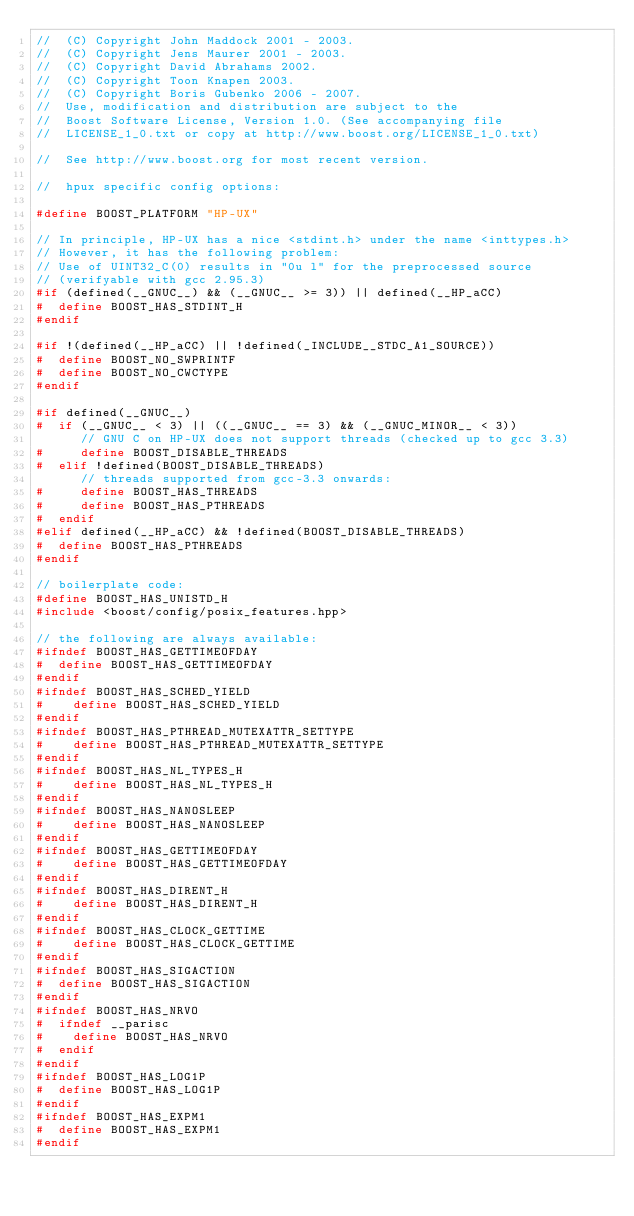Convert code to text. <code><loc_0><loc_0><loc_500><loc_500><_C++_>//  (C) Copyright John Maddock 2001 - 2003. 
//  (C) Copyright Jens Maurer 2001 - 2003. 
//  (C) Copyright David Abrahams 2002. 
//  (C) Copyright Toon Knapen 2003. 
//  (C) Copyright Boris Gubenko 2006 - 2007.
//  Use, modification and distribution are subject to the 
//  Boost Software License, Version 1.0. (See accompanying file 
//  LICENSE_1_0.txt or copy at http://www.boost.org/LICENSE_1_0.txt)

//  See http://www.boost.org for most recent version.

//  hpux specific config options:

#define BOOST_PLATFORM "HP-UX"

// In principle, HP-UX has a nice <stdint.h> under the name <inttypes.h>
// However, it has the following problem:
// Use of UINT32_C(0) results in "0u l" for the preprocessed source
// (verifyable with gcc 2.95.3)
#if (defined(__GNUC__) && (__GNUC__ >= 3)) || defined(__HP_aCC)
#  define BOOST_HAS_STDINT_H
#endif

#if !(defined(__HP_aCC) || !defined(_INCLUDE__STDC_A1_SOURCE))
#  define BOOST_NO_SWPRINTF
#  define BOOST_NO_CWCTYPE
#endif

#if defined(__GNUC__)
#  if (__GNUC__ < 3) || ((__GNUC__ == 3) && (__GNUC_MINOR__ < 3))
      // GNU C on HP-UX does not support threads (checked up to gcc 3.3)
#     define BOOST_DISABLE_THREADS
#  elif !defined(BOOST_DISABLE_THREADS)
      // threads supported from gcc-3.3 onwards:
#     define BOOST_HAS_THREADS
#     define BOOST_HAS_PTHREADS
#  endif
#elif defined(__HP_aCC) && !defined(BOOST_DISABLE_THREADS)
#  define BOOST_HAS_PTHREADS
#endif

// boilerplate code:
#define BOOST_HAS_UNISTD_H
#include <boost/config/posix_features.hpp>

// the following are always available:
#ifndef BOOST_HAS_GETTIMEOFDAY
#  define BOOST_HAS_GETTIMEOFDAY
#endif
#ifndef BOOST_HAS_SCHED_YIELD
#    define BOOST_HAS_SCHED_YIELD
#endif
#ifndef BOOST_HAS_PTHREAD_MUTEXATTR_SETTYPE
#    define BOOST_HAS_PTHREAD_MUTEXATTR_SETTYPE
#endif
#ifndef BOOST_HAS_NL_TYPES_H
#    define BOOST_HAS_NL_TYPES_H
#endif
#ifndef BOOST_HAS_NANOSLEEP
#    define BOOST_HAS_NANOSLEEP
#endif
#ifndef BOOST_HAS_GETTIMEOFDAY
#    define BOOST_HAS_GETTIMEOFDAY
#endif
#ifndef BOOST_HAS_DIRENT_H
#    define BOOST_HAS_DIRENT_H
#endif
#ifndef BOOST_HAS_CLOCK_GETTIME
#    define BOOST_HAS_CLOCK_GETTIME
#endif
#ifndef BOOST_HAS_SIGACTION
#  define BOOST_HAS_SIGACTION
#endif
#ifndef BOOST_HAS_NRVO 
#  ifndef __parisc
#    define BOOST_HAS_NRVO
#  endif
#endif
#ifndef BOOST_HAS_LOG1P 
#  define BOOST_HAS_LOG1P
#endif
#ifndef BOOST_HAS_EXPM1
#  define BOOST_HAS_EXPM1
#endif
</code> 